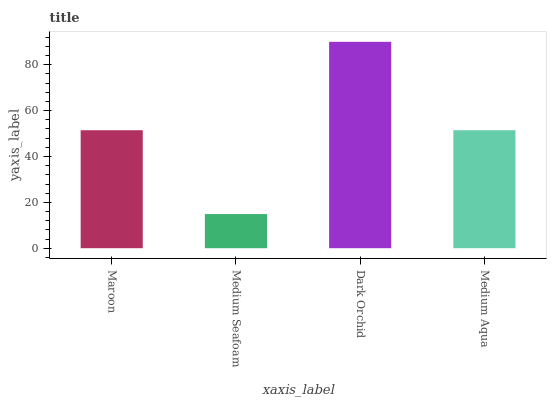Is Medium Seafoam the minimum?
Answer yes or no. Yes. Is Dark Orchid the maximum?
Answer yes or no. Yes. Is Dark Orchid the minimum?
Answer yes or no. No. Is Medium Seafoam the maximum?
Answer yes or no. No. Is Dark Orchid greater than Medium Seafoam?
Answer yes or no. Yes. Is Medium Seafoam less than Dark Orchid?
Answer yes or no. Yes. Is Medium Seafoam greater than Dark Orchid?
Answer yes or no. No. Is Dark Orchid less than Medium Seafoam?
Answer yes or no. No. Is Maroon the high median?
Answer yes or no. Yes. Is Medium Aqua the low median?
Answer yes or no. Yes. Is Medium Seafoam the high median?
Answer yes or no. No. Is Dark Orchid the low median?
Answer yes or no. No. 